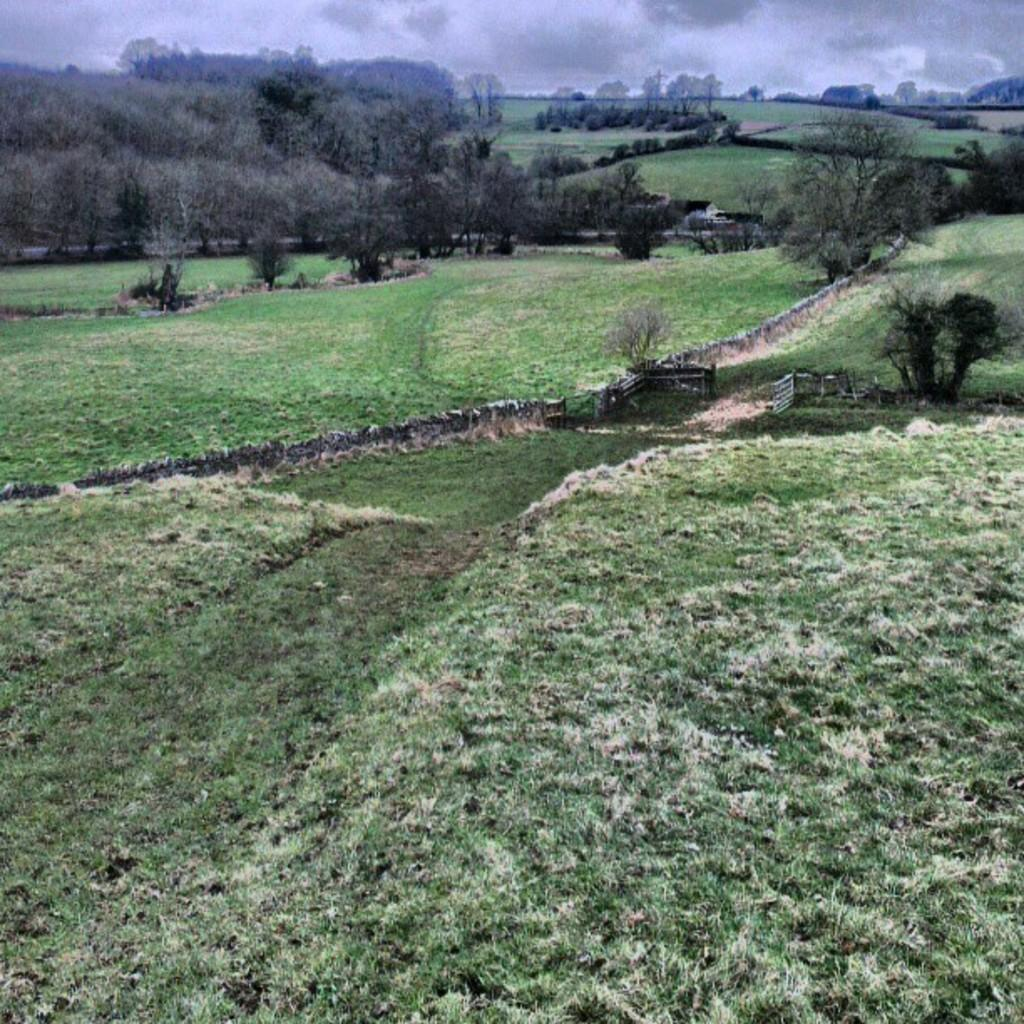What type of ground surface is visible in the image? There is grass on the ground in the image. What can be seen in the distance behind the grass? There are many trees and clouds visible in the background of the image. What part of the natural environment is visible in the image? The sky is visible in the background of the image. What type of zephyr can be seen blowing through the trees in the image? There is no zephyr present in the image; it is a meteorological term for a gentle breeze, and there is no indication of wind in the image. 